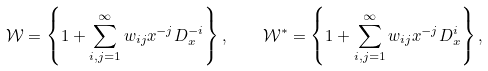<formula> <loc_0><loc_0><loc_500><loc_500>\mathcal { W } = \left \{ 1 + \sum _ { i , j = 1 } ^ { \infty } w _ { i j } x ^ { - j } D _ { x } ^ { - i } \right \} , \quad \mathcal { W } ^ { * } = \left \{ 1 + \sum _ { i , j = 1 } ^ { \infty } w _ { i j } x ^ { - j } D _ { x } ^ { i } \right \} ,</formula> 